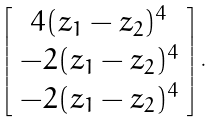Convert formula to latex. <formula><loc_0><loc_0><loc_500><loc_500>\left [ \begin{array} { c } 4 ( z _ { 1 } - z _ { 2 } ) ^ { 4 } \\ - 2 ( z _ { 1 } - z _ { 2 } ) ^ { 4 } \\ - 2 ( z _ { 1 } - z _ { 2 } ) ^ { 4 } \\ \end{array} \right ] .</formula> 